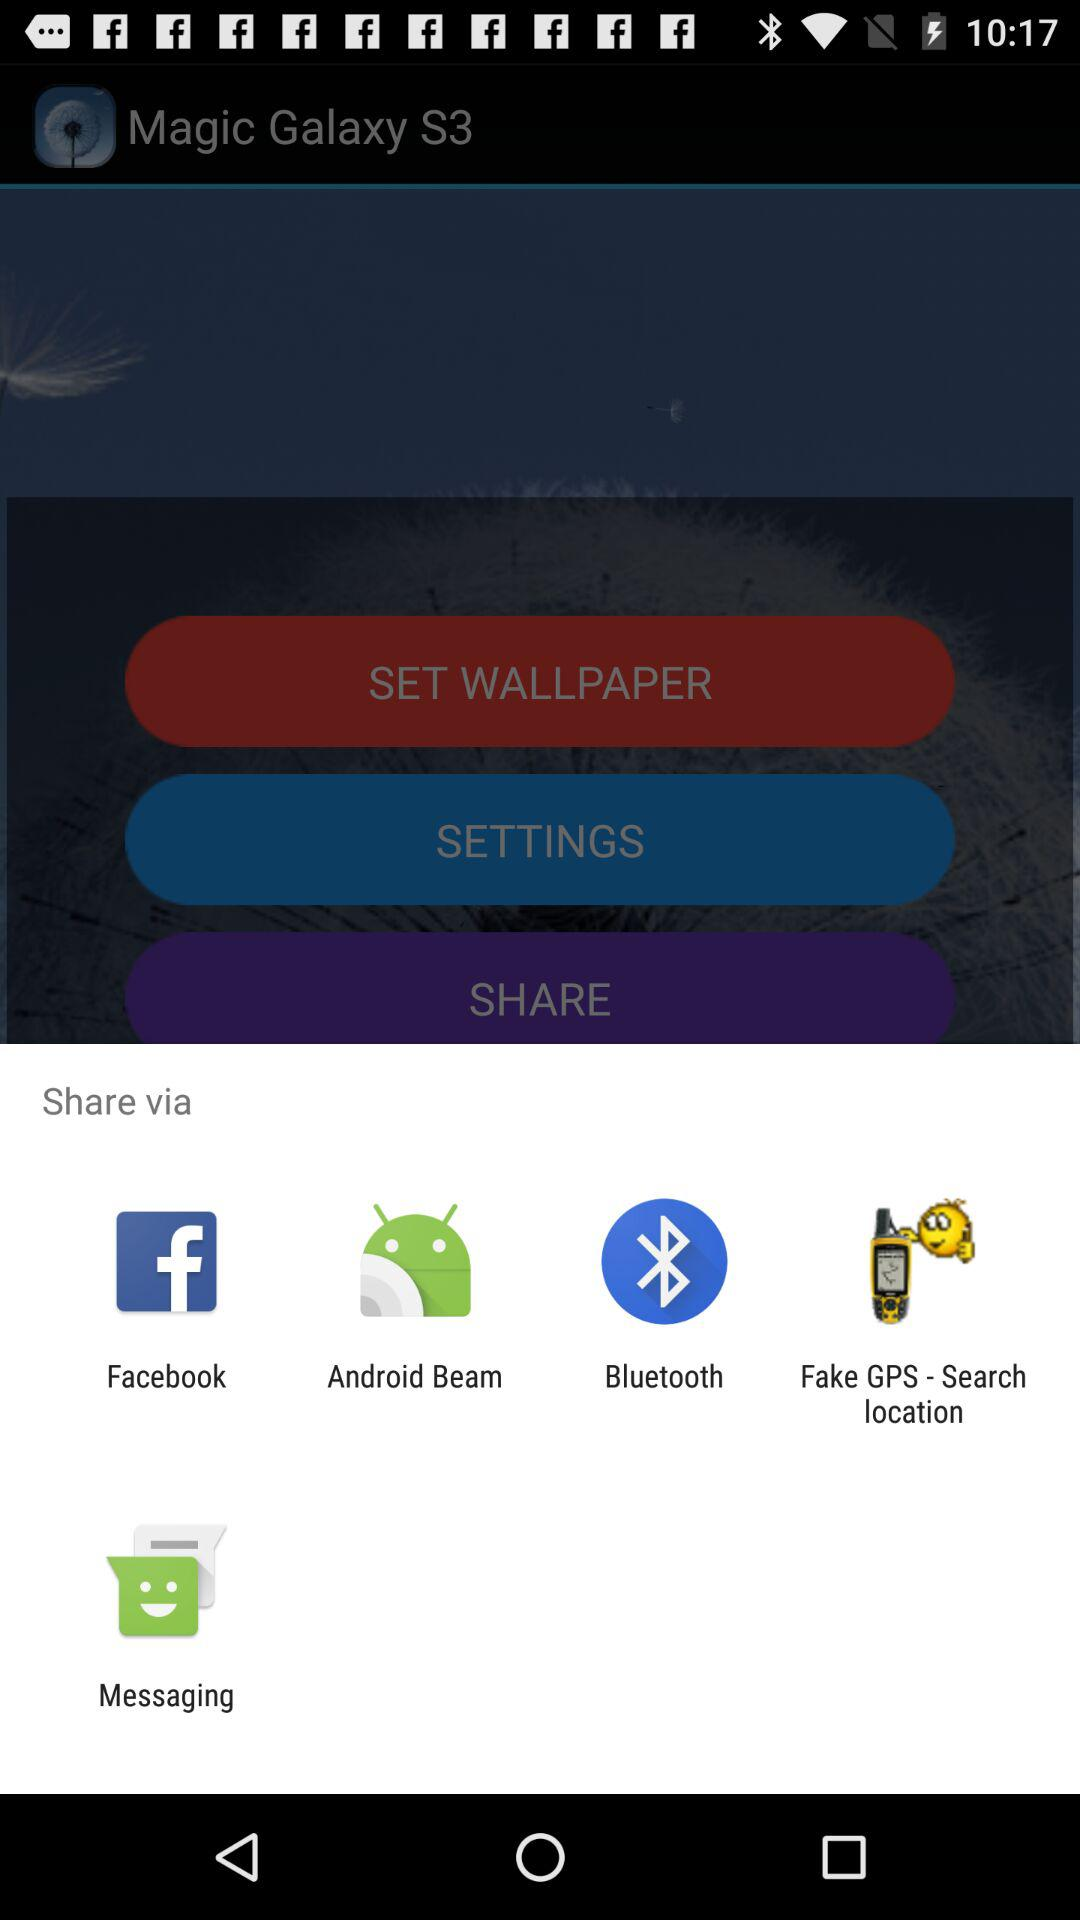What are the different applications that can be used to share? The different applications used to share are : "Facebook", "Android Beam", "Bluetooth","Fake GPS - Search location", and "Messaging". 